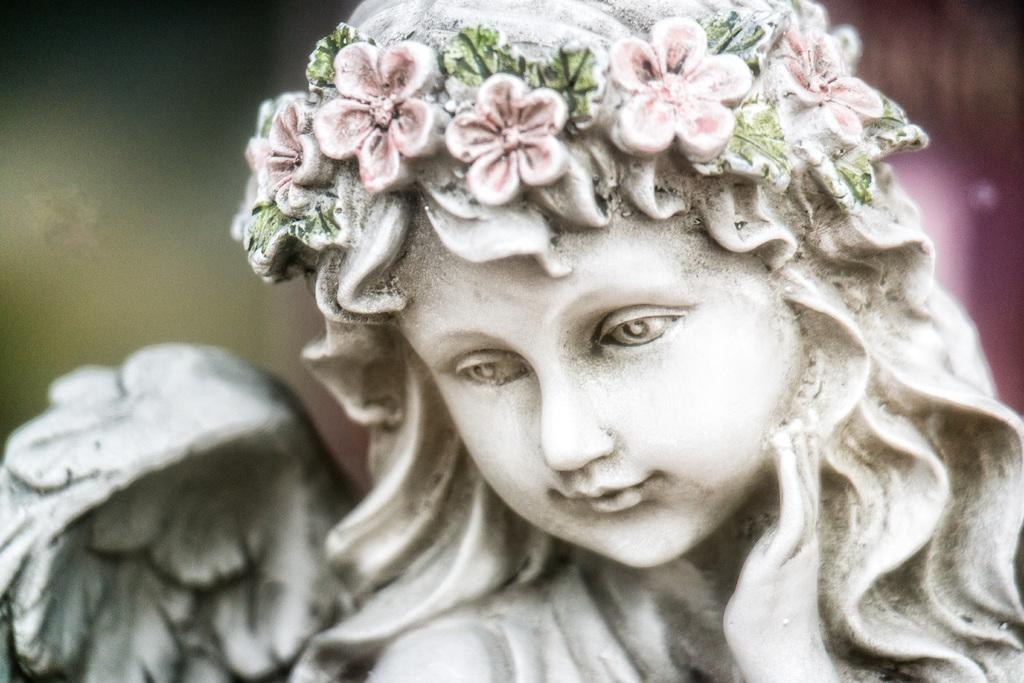What is the main subject of the image? There is a statue of a girl in the image. What is the girl wearing on her head? The girl is wearing a floral crown. How would you describe the background of the image? The background of the image is in green and pink colors, and it is blurred. What type of education is the girl receiving in the image? There is no indication in the image that the girl is receiving any education. Can you hear any noise in the image? The image is silent, as it is a still photograph. 